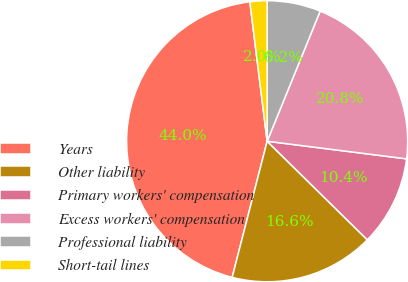Convert chart to OTSL. <chart><loc_0><loc_0><loc_500><loc_500><pie_chart><fcel>Years<fcel>Other liability<fcel>Primary workers' compensation<fcel>Excess workers' compensation<fcel>Professional liability<fcel>Short-tail lines<nl><fcel>44.03%<fcel>16.63%<fcel>10.37%<fcel>20.84%<fcel>6.16%<fcel>1.96%<nl></chart> 